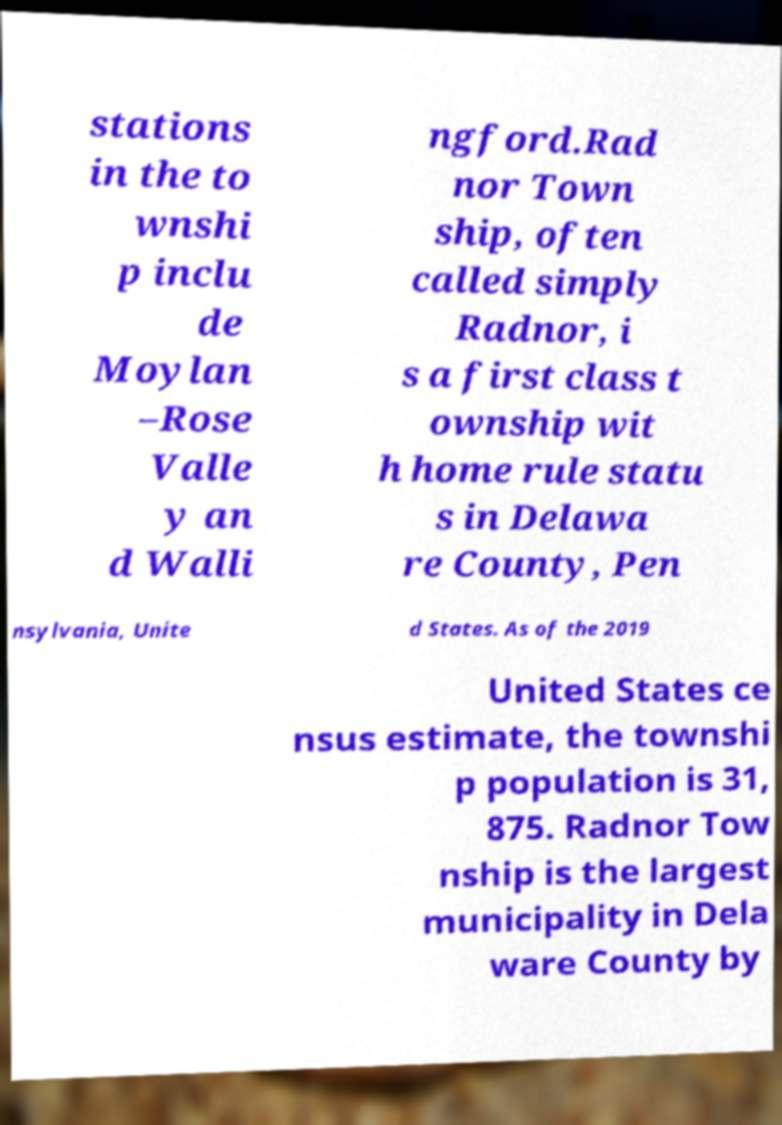Could you extract and type out the text from this image? stations in the to wnshi p inclu de Moylan –Rose Valle y an d Walli ngford.Rad nor Town ship, often called simply Radnor, i s a first class t ownship wit h home rule statu s in Delawa re County, Pen nsylvania, Unite d States. As of the 2019 United States ce nsus estimate, the townshi p population is 31, 875. Radnor Tow nship is the largest municipality in Dela ware County by 